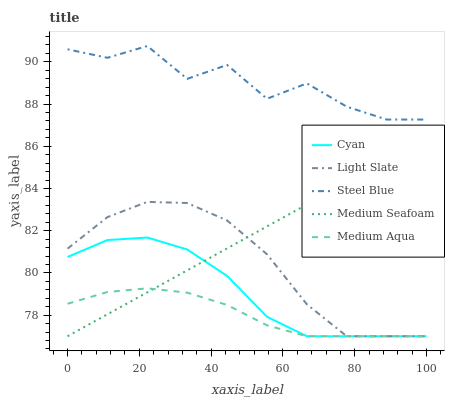Does Medium Aqua have the minimum area under the curve?
Answer yes or no. Yes. Does Steel Blue have the maximum area under the curve?
Answer yes or no. Yes. Does Cyan have the minimum area under the curve?
Answer yes or no. No. Does Cyan have the maximum area under the curve?
Answer yes or no. No. Is Medium Seafoam the smoothest?
Answer yes or no. Yes. Is Steel Blue the roughest?
Answer yes or no. Yes. Is Cyan the smoothest?
Answer yes or no. No. Is Cyan the roughest?
Answer yes or no. No. Does Light Slate have the lowest value?
Answer yes or no. Yes. Does Steel Blue have the lowest value?
Answer yes or no. No. Does Steel Blue have the highest value?
Answer yes or no. Yes. Does Cyan have the highest value?
Answer yes or no. No. Is Medium Aqua less than Steel Blue?
Answer yes or no. Yes. Is Steel Blue greater than Light Slate?
Answer yes or no. Yes. Does Light Slate intersect Cyan?
Answer yes or no. Yes. Is Light Slate less than Cyan?
Answer yes or no. No. Is Light Slate greater than Cyan?
Answer yes or no. No. Does Medium Aqua intersect Steel Blue?
Answer yes or no. No. 